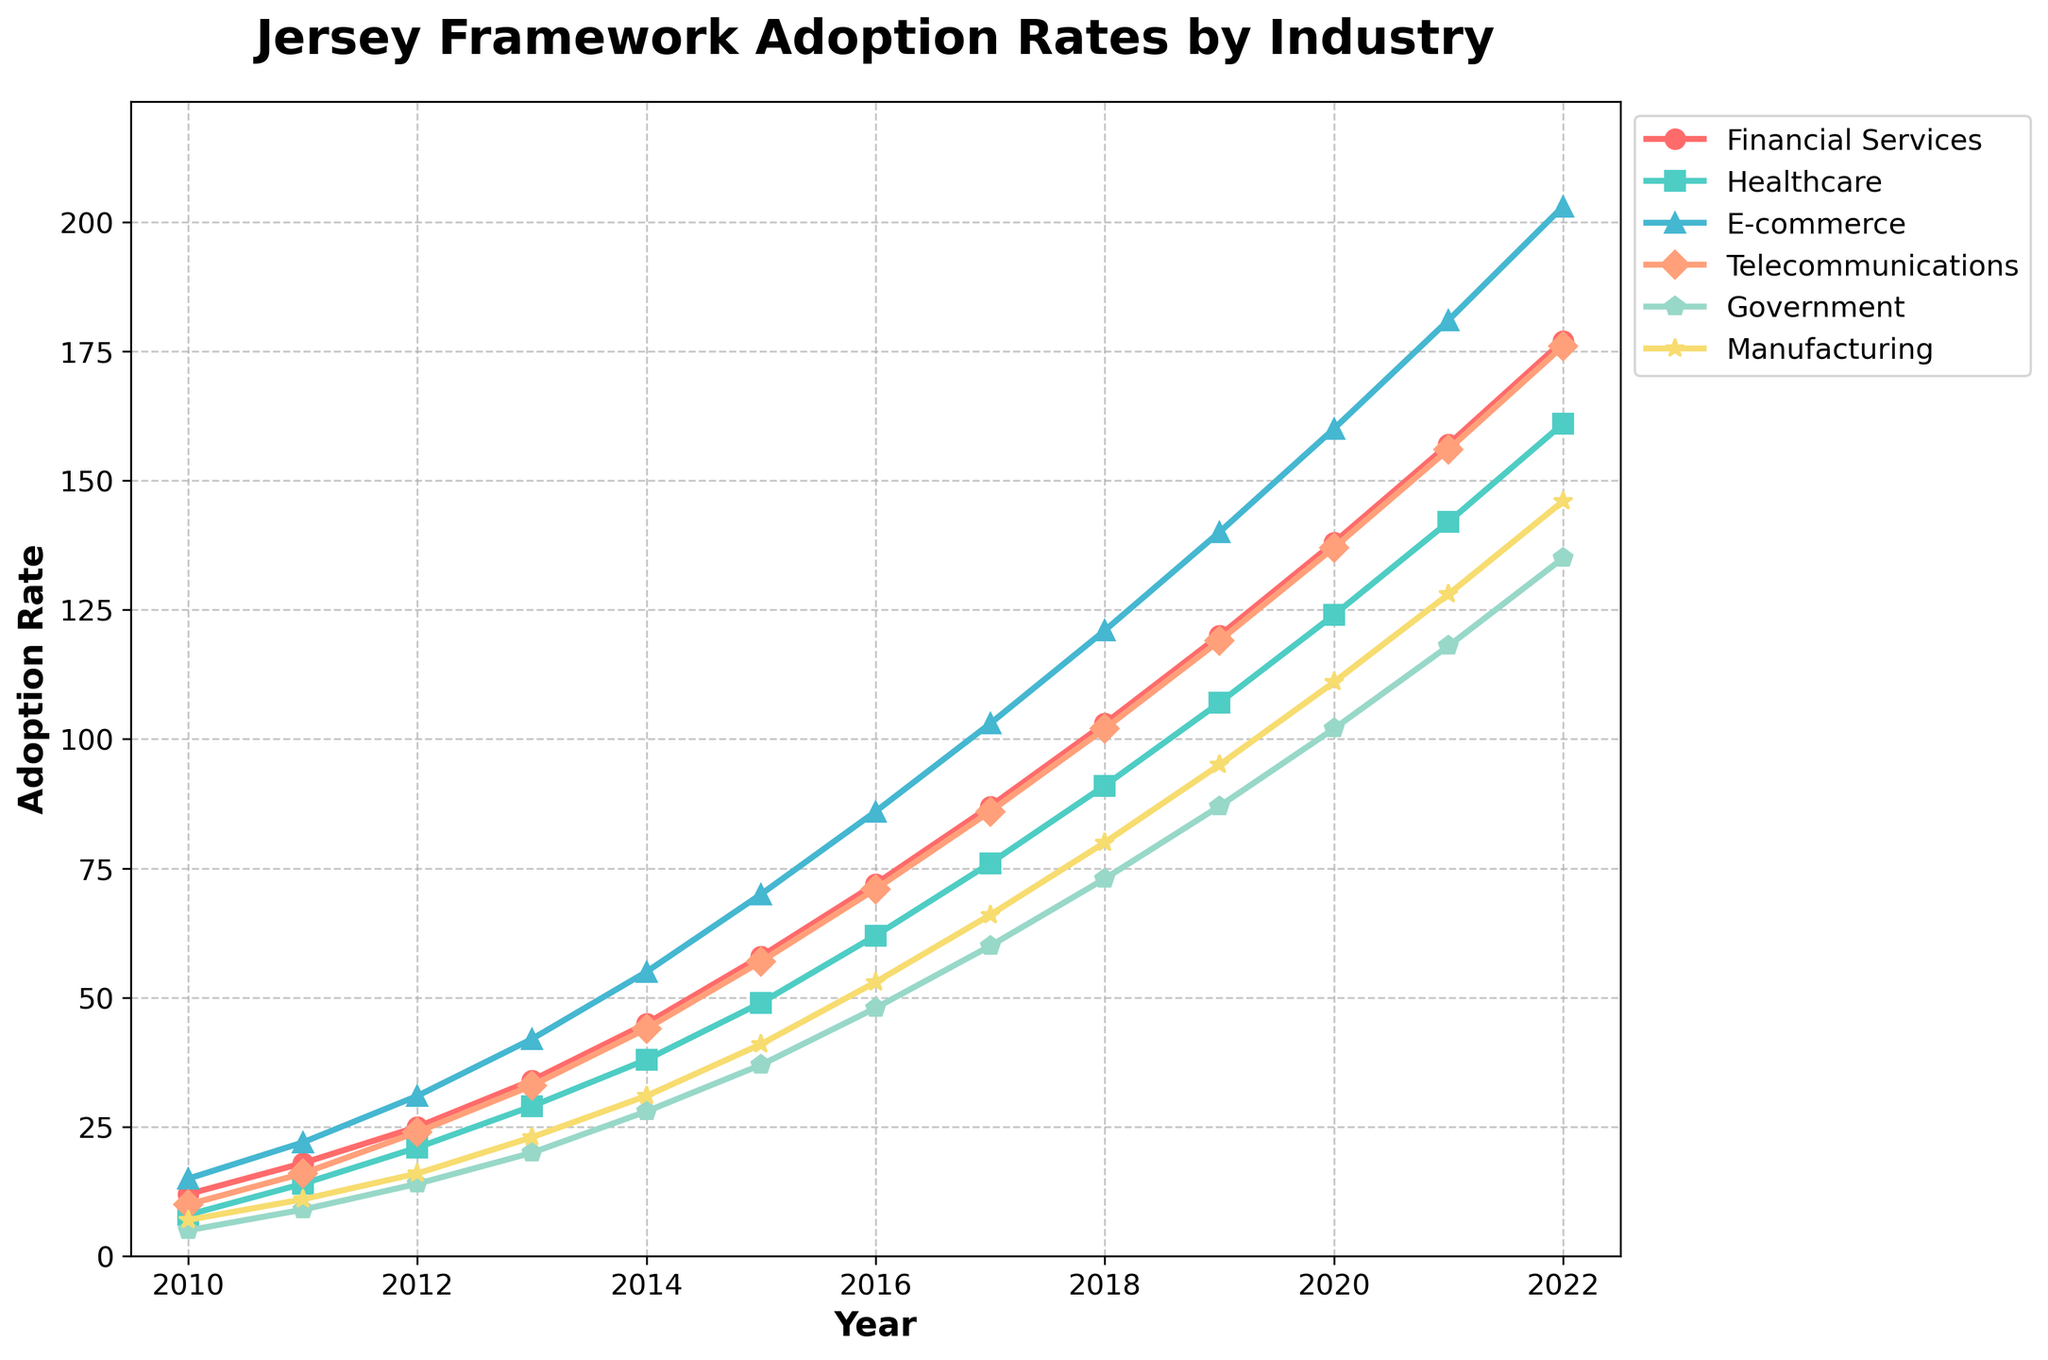Which industry had the highest Jersey framework adoption rate in 2022? To determine the highest adoption rate, look at the heights of the lines in 2022. The E-commerce sector reaches the highest point in that year.
Answer: E-commerce How did the adoption rate in Financial Services compare to Government in 2015? Observe the heights of the lines for Financial Services and Government in 2015. Financial Services had an adoption rate of 58 while Government had a rate of 37. Therefore, Financial Services had a higher adoption rate.
Answer: Financial Services What was the total adoption rate across all sectors in 2013? Add the adoption rates for all sectors in 2013: 34 (Financial Services) + 29 (Healthcare) + 42 (E-commerce) + 33 (Telecommunications) + 20 (Government) + 23 (Manufacturing) = 181.
Answer: 181 Which sector had the smallest growth in adoption rate from 2010 to 2022? Calculate the difference between the adoption rates in 2022 and 2010 for each sector. The differences are: Financial Services (165), Healthcare (153), E-commerce (188), Telecommunications (166), Government (130), Manufacturing (139). The Government sector has the smallest difference.
Answer: Government What is the average adoption rate in the Healthcare sector between 2010 and 2015? Compute the sum of the adoption rates from 2010 to 2015 and then divide by the number of years. (8+14+21+29+38+49)/6 = 159/6 = 26.5.
Answer: 26.5 By how much did the adoption rate in the Manufacturing sector change from 2017 to 2020? Subtract the adoption rate in 2017 from the rate in 2020: 111 (2020) - 66 (2017) = 45.
Answer: 45 Did the Telecommunications sector ever surpass the Financial Services sector in adoption rates between 2010 and 2022? Compare the adoption rates of Telecommunications and Financial Services each year. Telecommunications rates are consistently lower than Financial Services throughout the timeframe.
Answer: No What is the trend in the adoption rates for the Government sector from 2010 to 2022? Examine the line representing the Government sector from 2010 to 2022. The line shows a steady upward trend over the years.
Answer: Steady upward trend How much greater was the adoption rate of E-commerce compared to Healthcare in 2019? Subtract the Healthcare adoption rate from the E-commerce adoption rate in 2019: 140 (E-commerce) - 107 (Healthcare) = 33.
Answer: 33 